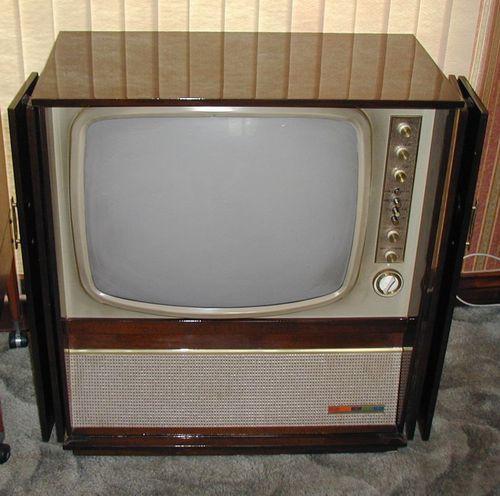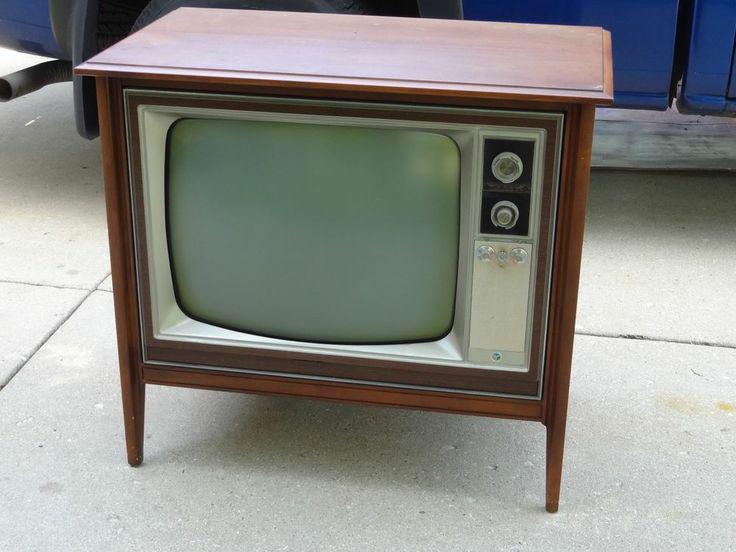The first image is the image on the left, the second image is the image on the right. Examine the images to the left and right. Is the description "One of the TV sets does not have legs under it." accurate? Answer yes or no. Yes. 